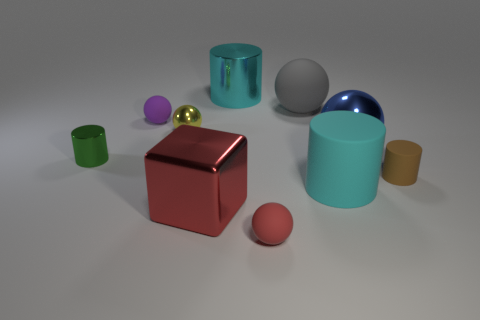Subtract all gray spheres. How many spheres are left? 4 Subtract all cubes. How many objects are left? 9 Subtract 1 cylinders. How many cylinders are left? 3 Subtract all brown cylinders. How many cylinders are left? 3 Subtract all red cylinders. Subtract all brown blocks. How many cylinders are left? 4 Subtract all red spheres. How many brown cylinders are left? 1 Subtract all small brown objects. Subtract all matte cylinders. How many objects are left? 7 Add 1 purple matte balls. How many purple matte balls are left? 2 Add 7 large cyan objects. How many large cyan objects exist? 9 Subtract 0 cyan blocks. How many objects are left? 10 